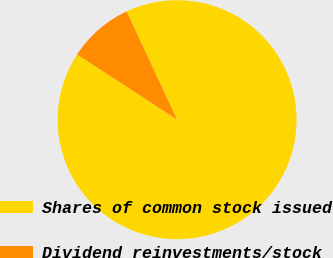<chart> <loc_0><loc_0><loc_500><loc_500><pie_chart><fcel>Shares of common stock issued<fcel>Dividend reinvestments/stock<nl><fcel>91.14%<fcel>8.86%<nl></chart> 